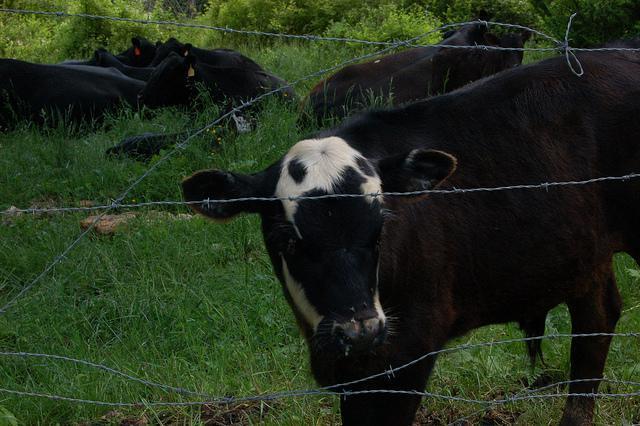How many cows are in the picture?
Give a very brief answer. 5. 